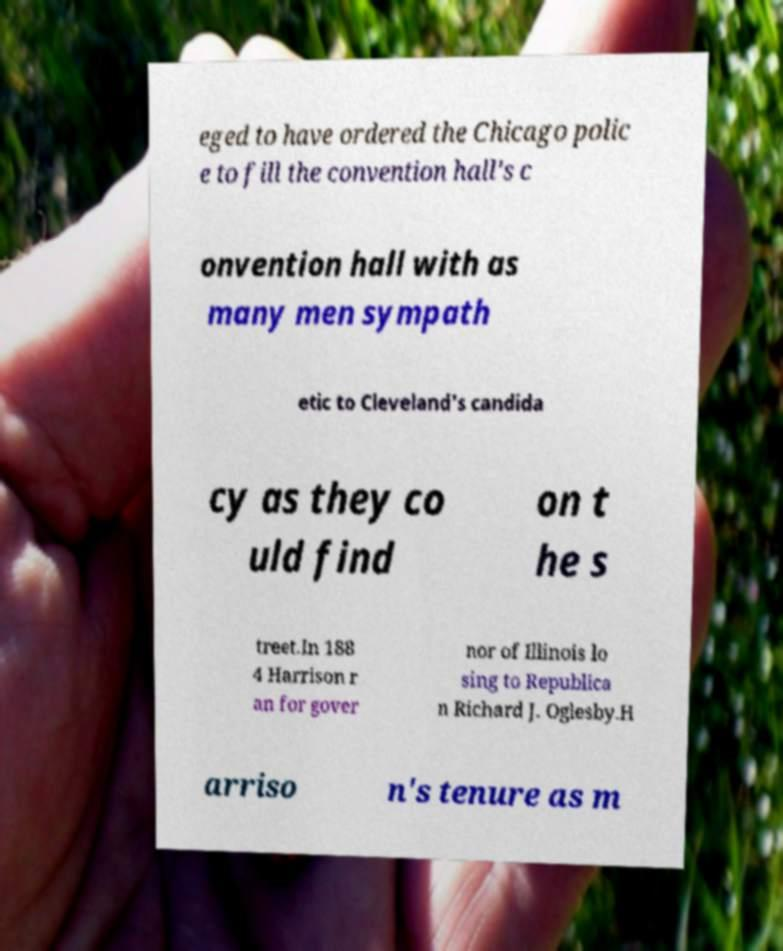What messages or text are displayed in this image? I need them in a readable, typed format. eged to have ordered the Chicago polic e to fill the convention hall's c onvention hall with as many men sympath etic to Cleveland's candida cy as they co uld find on t he s treet.In 188 4 Harrison r an for gover nor of Illinois lo sing to Republica n Richard J. Oglesby.H arriso n's tenure as m 